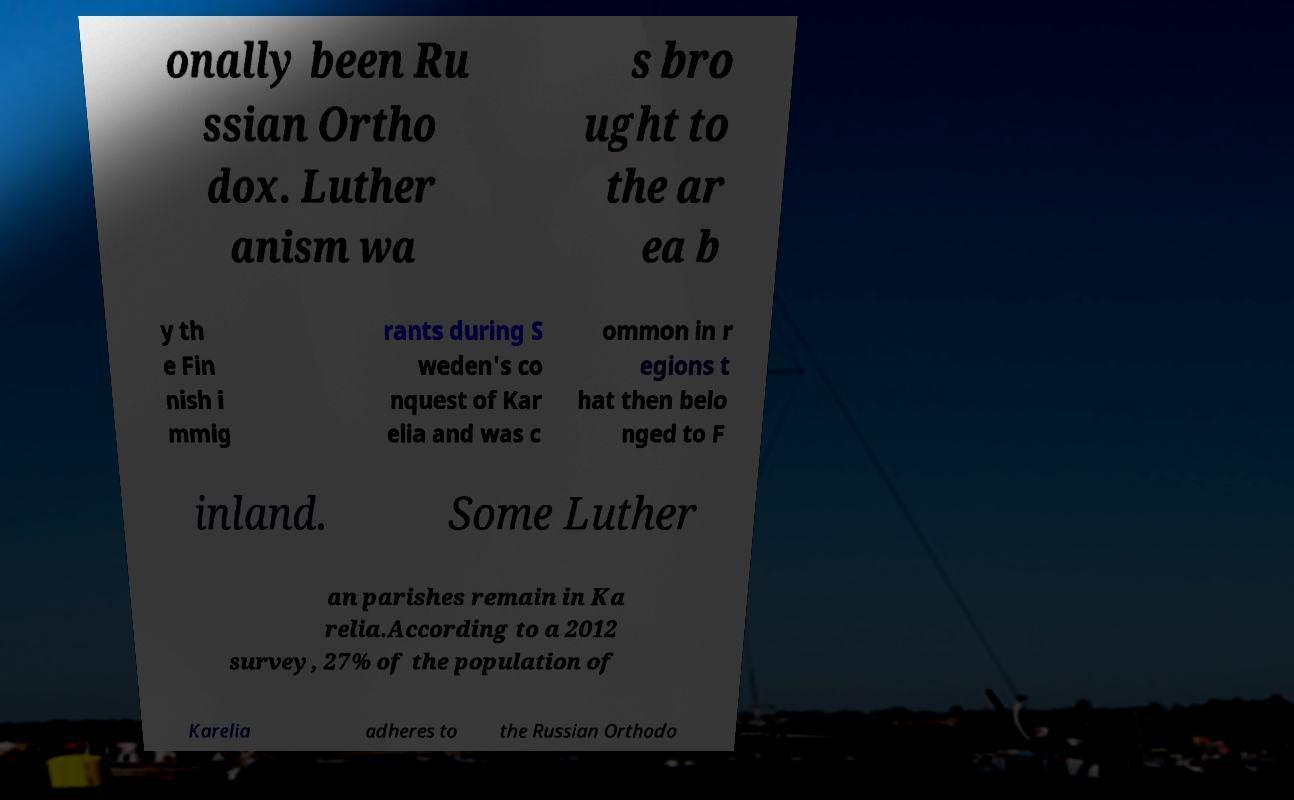Please read and relay the text visible in this image. What does it say? onally been Ru ssian Ortho dox. Luther anism wa s bro ught to the ar ea b y th e Fin nish i mmig rants during S weden's co nquest of Kar elia and was c ommon in r egions t hat then belo nged to F inland. Some Luther an parishes remain in Ka relia.According to a 2012 survey, 27% of the population of Karelia adheres to the Russian Orthodo 